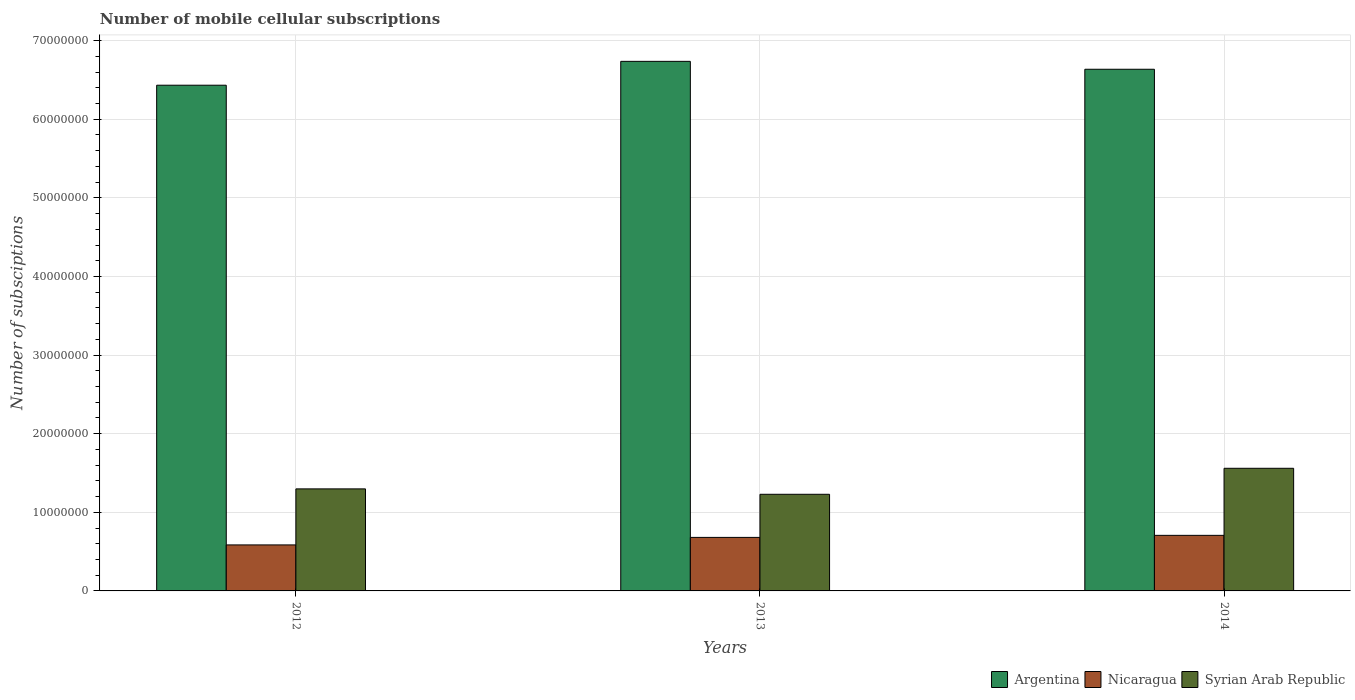How many groups of bars are there?
Make the answer very short. 3. Are the number of bars per tick equal to the number of legend labels?
Give a very brief answer. Yes. How many bars are there on the 2nd tick from the left?
Provide a short and direct response. 3. What is the number of mobile cellular subscriptions in Nicaragua in 2013?
Make the answer very short. 6.81e+06. Across all years, what is the maximum number of mobile cellular subscriptions in Syrian Arab Republic?
Make the answer very short. 1.56e+07. Across all years, what is the minimum number of mobile cellular subscriptions in Nicaragua?
Give a very brief answer. 5.85e+06. In which year was the number of mobile cellular subscriptions in Nicaragua minimum?
Offer a very short reply. 2012. What is the total number of mobile cellular subscriptions in Syrian Arab Republic in the graph?
Give a very brief answer. 4.09e+07. What is the difference between the number of mobile cellular subscriptions in Nicaragua in 2012 and that in 2014?
Offer a very short reply. -1.22e+06. What is the difference between the number of mobile cellular subscriptions in Nicaragua in 2012 and the number of mobile cellular subscriptions in Syrian Arab Republic in 2013?
Provide a succinct answer. -6.44e+06. What is the average number of mobile cellular subscriptions in Argentina per year?
Keep it short and to the point. 6.60e+07. In the year 2013, what is the difference between the number of mobile cellular subscriptions in Argentina and number of mobile cellular subscriptions in Syrian Arab Republic?
Your answer should be compact. 5.51e+07. In how many years, is the number of mobile cellular subscriptions in Argentina greater than 36000000?
Offer a very short reply. 3. What is the ratio of the number of mobile cellular subscriptions in Nicaragua in 2013 to that in 2014?
Give a very brief answer. 0.96. Is the number of mobile cellular subscriptions in Nicaragua in 2012 less than that in 2013?
Provide a short and direct response. Yes. What is the difference between the highest and the second highest number of mobile cellular subscriptions in Syrian Arab Republic?
Offer a very short reply. 2.62e+06. What is the difference between the highest and the lowest number of mobile cellular subscriptions in Nicaragua?
Your answer should be very brief. 1.22e+06. What does the 2nd bar from the left in 2014 represents?
Keep it short and to the point. Nicaragua. What does the 2nd bar from the right in 2013 represents?
Offer a terse response. Nicaragua. Is it the case that in every year, the sum of the number of mobile cellular subscriptions in Nicaragua and number of mobile cellular subscriptions in Argentina is greater than the number of mobile cellular subscriptions in Syrian Arab Republic?
Your response must be concise. Yes. What is the difference between two consecutive major ticks on the Y-axis?
Your answer should be very brief. 1.00e+07. Are the values on the major ticks of Y-axis written in scientific E-notation?
Provide a succinct answer. No. What is the title of the graph?
Make the answer very short. Number of mobile cellular subscriptions. What is the label or title of the Y-axis?
Give a very brief answer. Number of subsciptions. What is the Number of subsciptions in Argentina in 2012?
Provide a succinct answer. 6.43e+07. What is the Number of subsciptions in Nicaragua in 2012?
Ensure brevity in your answer.  5.85e+06. What is the Number of subsciptions of Syrian Arab Republic in 2012?
Your answer should be compact. 1.30e+07. What is the Number of subsciptions in Argentina in 2013?
Provide a succinct answer. 6.74e+07. What is the Number of subsciptions of Nicaragua in 2013?
Provide a succinct answer. 6.81e+06. What is the Number of subsciptions in Syrian Arab Republic in 2013?
Offer a terse response. 1.23e+07. What is the Number of subsciptions in Argentina in 2014?
Offer a terse response. 6.64e+07. What is the Number of subsciptions in Nicaragua in 2014?
Provide a succinct answer. 7.07e+06. What is the Number of subsciptions of Syrian Arab Republic in 2014?
Offer a terse response. 1.56e+07. Across all years, what is the maximum Number of subsciptions in Argentina?
Offer a terse response. 6.74e+07. Across all years, what is the maximum Number of subsciptions in Nicaragua?
Your answer should be very brief. 7.07e+06. Across all years, what is the maximum Number of subsciptions of Syrian Arab Republic?
Offer a very short reply. 1.56e+07. Across all years, what is the minimum Number of subsciptions in Argentina?
Give a very brief answer. 6.43e+07. Across all years, what is the minimum Number of subsciptions of Nicaragua?
Provide a succinct answer. 5.85e+06. Across all years, what is the minimum Number of subsciptions in Syrian Arab Republic?
Offer a terse response. 1.23e+07. What is the total Number of subsciptions in Argentina in the graph?
Offer a terse response. 1.98e+08. What is the total Number of subsciptions in Nicaragua in the graph?
Provide a short and direct response. 1.97e+07. What is the total Number of subsciptions in Syrian Arab Republic in the graph?
Your answer should be compact. 4.09e+07. What is the difference between the Number of subsciptions in Argentina in 2012 and that in 2013?
Provide a short and direct response. -3.03e+06. What is the difference between the Number of subsciptions in Nicaragua in 2012 and that in 2013?
Provide a succinct answer. -9.57e+05. What is the difference between the Number of subsciptions of Syrian Arab Republic in 2012 and that in 2013?
Ensure brevity in your answer.  6.89e+05. What is the difference between the Number of subsciptions in Argentina in 2012 and that in 2014?
Ensure brevity in your answer.  -2.03e+06. What is the difference between the Number of subsciptions in Nicaragua in 2012 and that in 2014?
Provide a short and direct response. -1.22e+06. What is the difference between the Number of subsciptions of Syrian Arab Republic in 2012 and that in 2014?
Your response must be concise. -2.62e+06. What is the difference between the Number of subsciptions of Argentina in 2013 and that in 2014?
Your answer should be compact. 1.01e+06. What is the difference between the Number of subsciptions in Nicaragua in 2013 and that in 2014?
Your answer should be very brief. -2.59e+05. What is the difference between the Number of subsciptions in Syrian Arab Republic in 2013 and that in 2014?
Give a very brief answer. -3.31e+06. What is the difference between the Number of subsciptions in Argentina in 2012 and the Number of subsciptions in Nicaragua in 2013?
Offer a terse response. 5.75e+07. What is the difference between the Number of subsciptions of Argentina in 2012 and the Number of subsciptions of Syrian Arab Republic in 2013?
Your response must be concise. 5.20e+07. What is the difference between the Number of subsciptions in Nicaragua in 2012 and the Number of subsciptions in Syrian Arab Republic in 2013?
Your response must be concise. -6.44e+06. What is the difference between the Number of subsciptions of Argentina in 2012 and the Number of subsciptions of Nicaragua in 2014?
Your answer should be compact. 5.73e+07. What is the difference between the Number of subsciptions of Argentina in 2012 and the Number of subsciptions of Syrian Arab Republic in 2014?
Give a very brief answer. 4.87e+07. What is the difference between the Number of subsciptions in Nicaragua in 2012 and the Number of subsciptions in Syrian Arab Republic in 2014?
Make the answer very short. -9.75e+06. What is the difference between the Number of subsciptions in Argentina in 2013 and the Number of subsciptions in Nicaragua in 2014?
Ensure brevity in your answer.  6.03e+07. What is the difference between the Number of subsciptions of Argentina in 2013 and the Number of subsciptions of Syrian Arab Republic in 2014?
Your answer should be very brief. 5.18e+07. What is the difference between the Number of subsciptions of Nicaragua in 2013 and the Number of subsciptions of Syrian Arab Republic in 2014?
Make the answer very short. -8.79e+06. What is the average Number of subsciptions in Argentina per year?
Keep it short and to the point. 6.60e+07. What is the average Number of subsciptions of Nicaragua per year?
Your answer should be very brief. 6.58e+06. What is the average Number of subsciptions in Syrian Arab Republic per year?
Your answer should be very brief. 1.36e+07. In the year 2012, what is the difference between the Number of subsciptions of Argentina and Number of subsciptions of Nicaragua?
Offer a terse response. 5.85e+07. In the year 2012, what is the difference between the Number of subsciptions of Argentina and Number of subsciptions of Syrian Arab Republic?
Your response must be concise. 5.13e+07. In the year 2012, what is the difference between the Number of subsciptions in Nicaragua and Number of subsciptions in Syrian Arab Republic?
Your response must be concise. -7.13e+06. In the year 2013, what is the difference between the Number of subsciptions of Argentina and Number of subsciptions of Nicaragua?
Make the answer very short. 6.06e+07. In the year 2013, what is the difference between the Number of subsciptions of Argentina and Number of subsciptions of Syrian Arab Republic?
Provide a short and direct response. 5.51e+07. In the year 2013, what is the difference between the Number of subsciptions in Nicaragua and Number of subsciptions in Syrian Arab Republic?
Make the answer very short. -5.48e+06. In the year 2014, what is the difference between the Number of subsciptions in Argentina and Number of subsciptions in Nicaragua?
Offer a terse response. 5.93e+07. In the year 2014, what is the difference between the Number of subsciptions of Argentina and Number of subsciptions of Syrian Arab Republic?
Provide a short and direct response. 5.08e+07. In the year 2014, what is the difference between the Number of subsciptions of Nicaragua and Number of subsciptions of Syrian Arab Republic?
Provide a succinct answer. -8.53e+06. What is the ratio of the Number of subsciptions of Argentina in 2012 to that in 2013?
Ensure brevity in your answer.  0.95. What is the ratio of the Number of subsciptions of Nicaragua in 2012 to that in 2013?
Ensure brevity in your answer.  0.86. What is the ratio of the Number of subsciptions in Syrian Arab Republic in 2012 to that in 2013?
Provide a short and direct response. 1.06. What is the ratio of the Number of subsciptions of Argentina in 2012 to that in 2014?
Your response must be concise. 0.97. What is the ratio of the Number of subsciptions in Nicaragua in 2012 to that in 2014?
Provide a short and direct response. 0.83. What is the ratio of the Number of subsciptions in Syrian Arab Republic in 2012 to that in 2014?
Offer a very short reply. 0.83. What is the ratio of the Number of subsciptions of Argentina in 2013 to that in 2014?
Your answer should be compact. 1.02. What is the ratio of the Number of subsciptions of Nicaragua in 2013 to that in 2014?
Provide a short and direct response. 0.96. What is the ratio of the Number of subsciptions in Syrian Arab Republic in 2013 to that in 2014?
Keep it short and to the point. 0.79. What is the difference between the highest and the second highest Number of subsciptions in Argentina?
Your response must be concise. 1.01e+06. What is the difference between the highest and the second highest Number of subsciptions of Nicaragua?
Offer a terse response. 2.59e+05. What is the difference between the highest and the second highest Number of subsciptions in Syrian Arab Republic?
Provide a succinct answer. 2.62e+06. What is the difference between the highest and the lowest Number of subsciptions in Argentina?
Offer a very short reply. 3.03e+06. What is the difference between the highest and the lowest Number of subsciptions in Nicaragua?
Keep it short and to the point. 1.22e+06. What is the difference between the highest and the lowest Number of subsciptions of Syrian Arab Republic?
Your answer should be compact. 3.31e+06. 